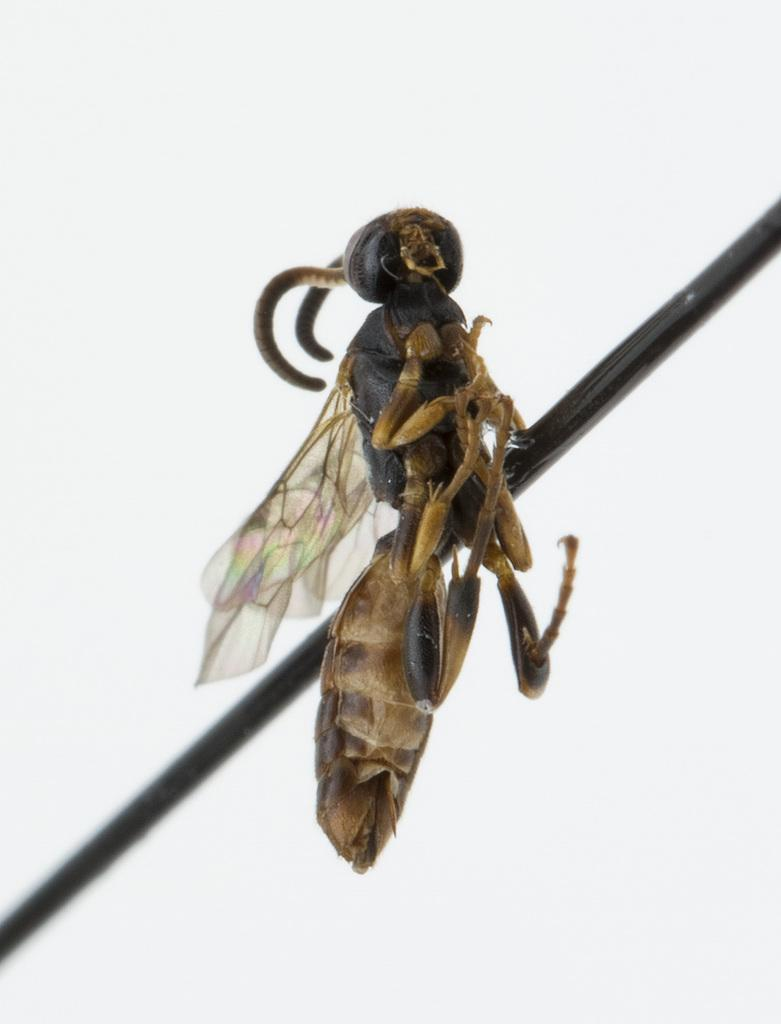What type of insect is present in the image? There is a hornet insect in the picture. What type of haircut does the hornet insect have in the image? The hornet insect does not have a haircut, as it is an insect and not a human or animal with hair. 